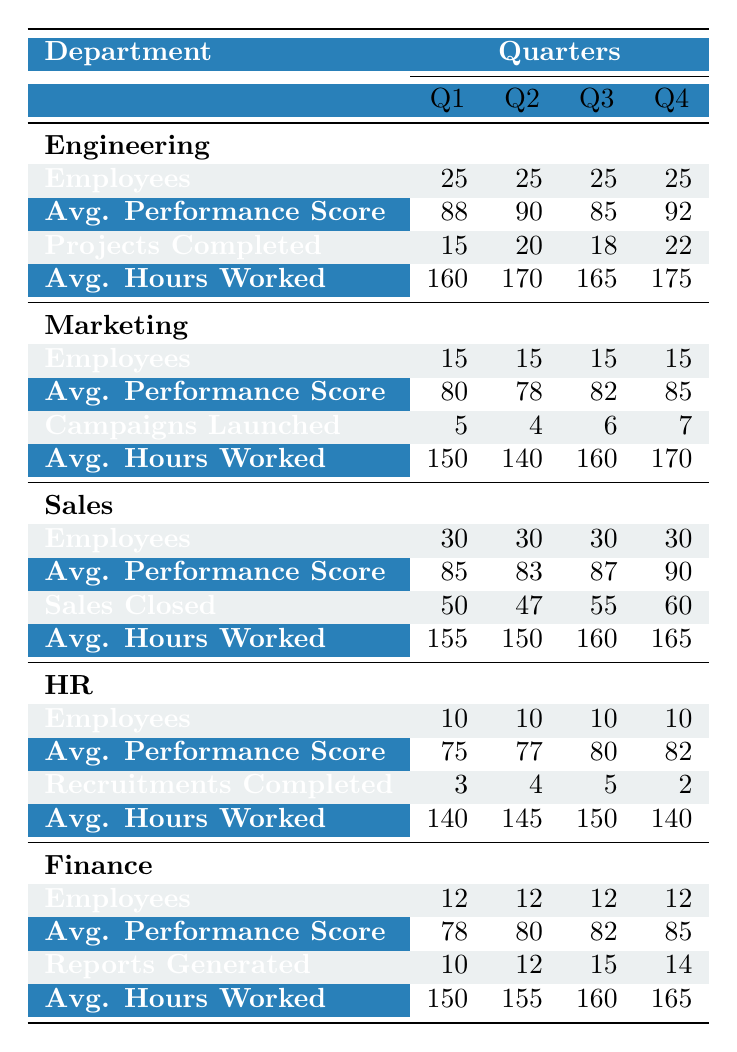What is the average performance score for the Engineering department in Q2? The table shows that the average performance score for Engineering in Q2 is 90.
Answer: 90 How many employees worked in the Sales department during Q3? The table indicates that there were 30 employees in the Sales department in Q3.
Answer: 30 What is the total number of projects completed by the Engineering department in Q1 and Q4? In Q1, Engineering completed 15 projects, and in Q4, they completed 22 projects. Summing these gives 15 + 22 = 37.
Answer: 37 Did the Marketing department launch more campaigns in Q4 than Q1? In Q4, the Marketing department launched 7 campaigns, while in Q1, they launched 5. Therefore, yes, they launched more in Q4 than in Q1.
Answer: Yes What is the average number of hours worked by the HR department throughout the year? The average hours for HR across all quarters are: (140 + 145 + 150 + 140) / 4 = 145.
Answer: 145 Which department had the highest average performance score in Q3? The average performance scores in Q3 were: Engineering (85), Marketing (82), Sales (87), HR (80), and Finance (82). Sales had the highest score of 87 in Q3.
Answer: Sales How many total reports were generated by the Finance department in Q1 and Q3? In Q1, 10 reports were generated, and in Q3, 15 reports were generated. Therefore, the total is 10 + 15 = 25 reports.
Answer: 25 Was the average performance score of the HR department higher in Q4 than in Q2? The average performance score for HR in Q4 is 82, and in Q2 it is 77. Since 82 > 77, the average score in Q4 is higher.
Answer: Yes What is the average hours worked by the Marketing employees in Q2? The table indicates that the average hours worked by Marketing employees in Q2 is 140.
Answer: 140 Which department had the least number of employees and how many? The HR department had the least number of employees, with a total of 10.
Answer: 10 What is the difference between the average performance scores of Engineering in Q4 and Q1? The average performance score for Engineering in Q4 is 92, and in Q1 it is 88. The difference is 92 - 88 = 4.
Answer: 4 